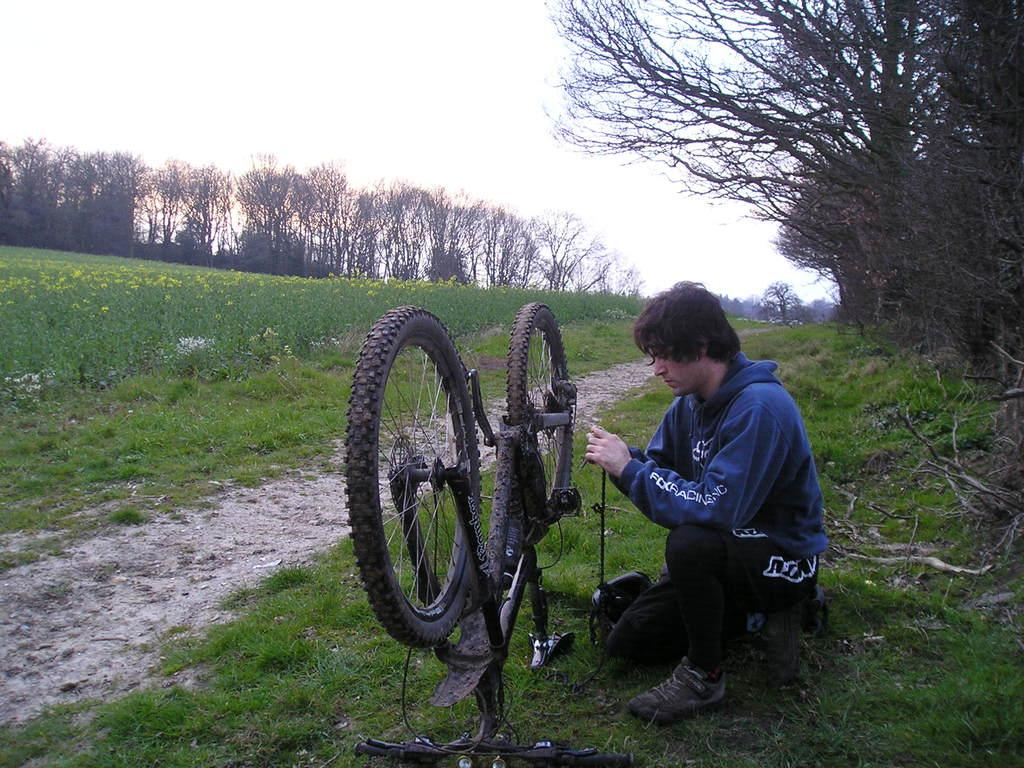What is the person in the image doing? The person is sitting on the grass in the image. What object is in front of the person? There is a cycle in front of the person. What type of vegetation can be seen in the image? There are plants and trees in the image. What is visible at the top of the image? The sky is visible at the top of the image. What type of farm animals can be heard on the island in the image? There is no farm or island present in the image, and therefore no such animals can be heard. 